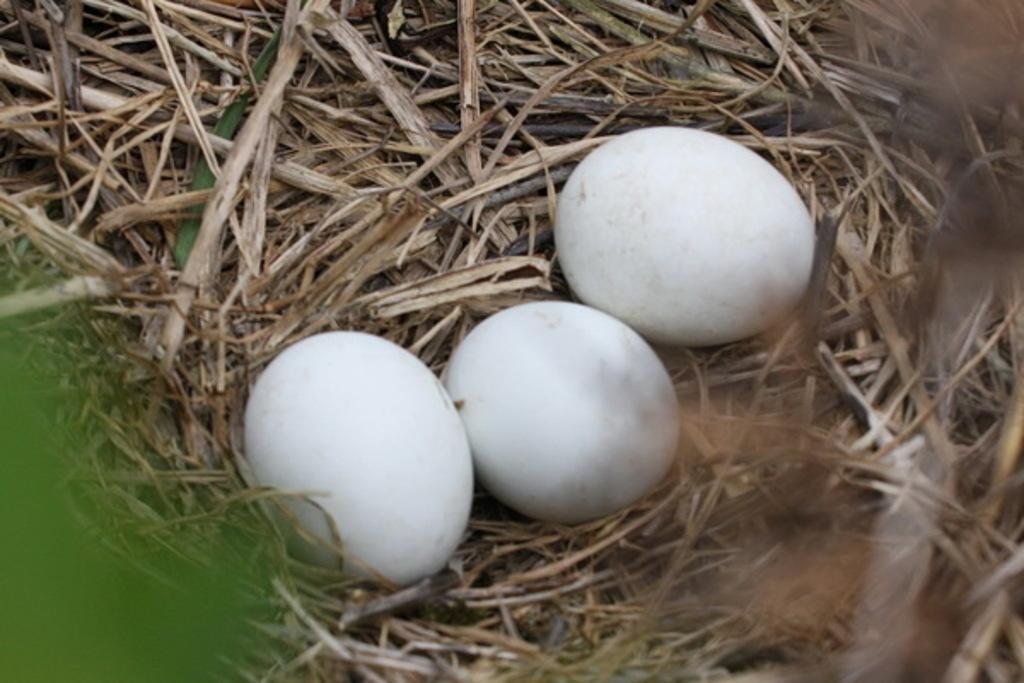What type of objects can be seen in the image? There are three white color eggs in the image. What is the texture or appearance of the ground in the image? There is dry grass in the image. What type of wall can be seen in the image? There is no wall present in the image; it features three white color eggs and dry grass. How many waves can be seen crashing on the shore in the image? There is no shore or waves present in the image; it features three white color eggs and dry grass. 